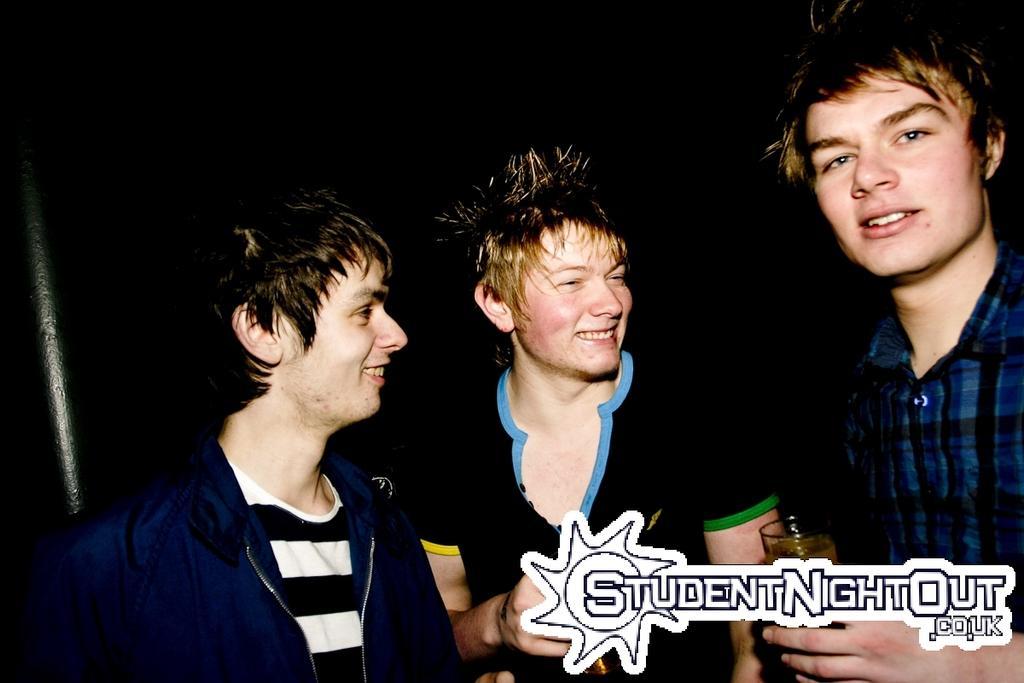Please provide a concise description of this image. In the picture I can see three persons standing where two among them are holding a glass of drink in their hands and there is something written in the right bottom corner. 